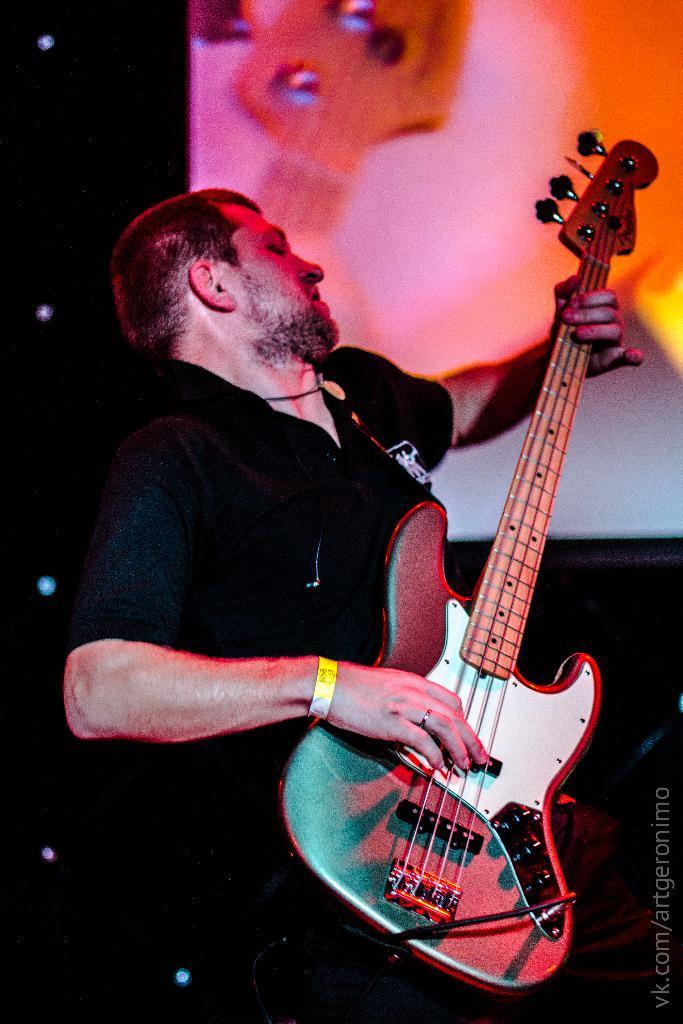Can you describe this image briefly? In the center of the image there is a man playing a guitar. He is wearing a black shirt. In the background there is a board. 